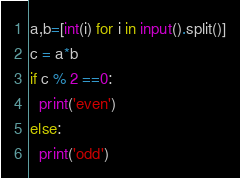<code> <loc_0><loc_0><loc_500><loc_500><_Python_>a,b=[int(i) for i in input().split()]
c = a*b
if c % 2 ==0:
  print('even')
else:
  print('odd')</code> 